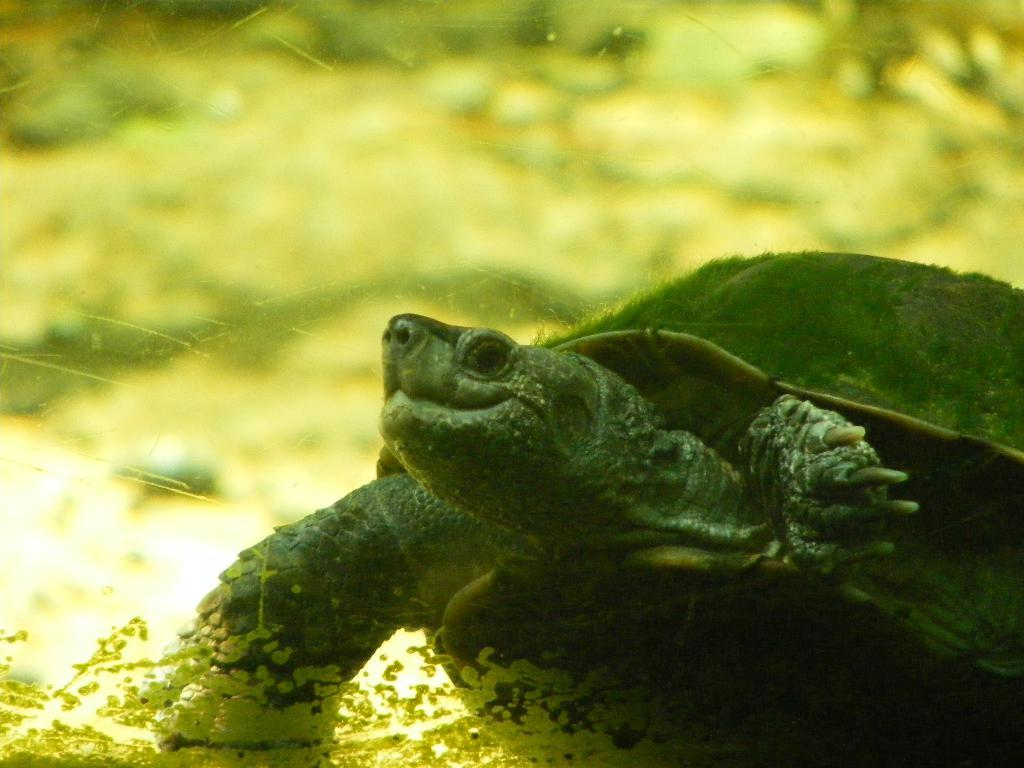Where was the image taken? The image was taken outdoors. What can be observed about the background of the image? The background of the image is blurred. What animal is present on the right side of the image? There is a tortoise on the right side of the image. What is located in the middle of the image? There is a spider web in the middle of the image. What type of leg is visible in the image? There is no leg visible in the image. What season is it in the image? The provided facts do not mention the season, so it cannot be determined from the image. 